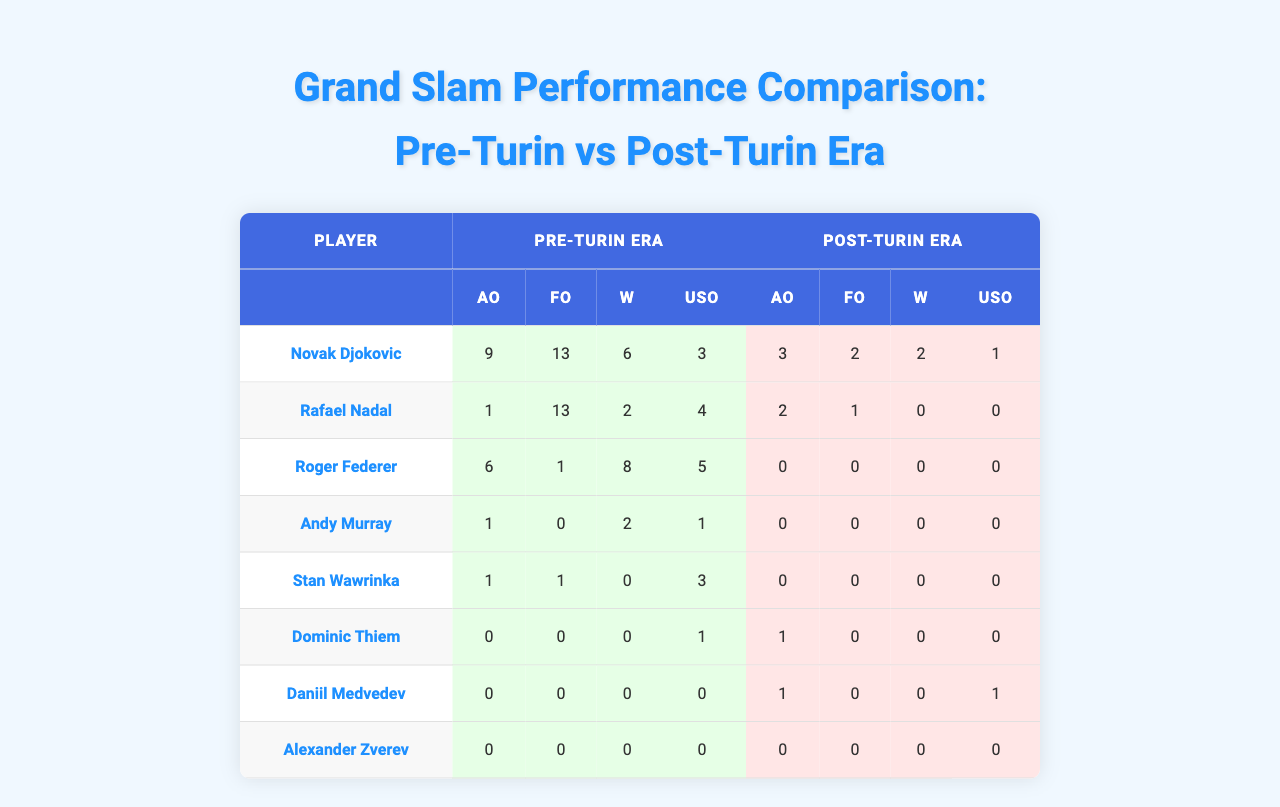What is the total number of Australian Open titles won by Novak Djokovic in the pre-Turin era? Referring to the table, the "Pre-Turin Era" column for Novak Djokovic under Australian Open shows a count of 9 titles.
Answer: 9 How many Grand Slam titles did Rafael Nadal win in the French Open during the post-Turin era? The table indicates that Rafael Nadal won 1 title in the French Open when examining the "Post-Turin Era" column.
Answer: 1 What was the total number of titles won by Andy Murray in the pre-Turin era? Adding up the values in the pre-Turin era for Andy Murray: (1 + 0 + 2 + 1) = 4 titles.
Answer: 4 Did Roger Federer win any titles in the post-Turin era? Looking at the table, Roger Federer has 0 titles in all Grand Slam categories for the post-Turin era. Therefore, the answer is no.
Answer: No Compare the total number of Wimbledon titles won by Stan Wawrinka in both eras. In the pre-Turin era, Stan Wawrinka had 0 titles, while in the post-Turin era, he also had 0 titles. Thus, there is no change.
Answer: No change Which player had the most Grand Slam titles in the Australian Open during the pre-Turin era? Novak Djokovic with 9 titles had the highest count in the Australian Open for the pre-Turin era.
Answer: Novak Djokovic Are there any players who did not win any Grand Slam titles in the post-Turin era? Analyzing the post-Turin era titles, both Andy Murray and Stan Wawrinka won 0 titles, confirming the statement is true.
Answer: Yes Which player had a decrease in total Grand Slam titles from the pre-Turin era to the post-Turin era? By comparing totals, both Novak Djokovic and Rafael Nadal had titles in the pre-Turin era, but their counts decreased in the post-Turin era, confirming a decrease.
Answer: Novak Djokovic and Rafael Nadal What is the difference in the total titles won by Daniil Medvedev between both eras? Adding Daniil Medvedev’s titles: 0 in pre-Turin and 2 in post-Turin gives a total of 2, showing an increase of 2 titles from one era to the next.
Answer: 2 titles increase What is the sum of all Grand Slam titles won by Roger Federer in both eras? For Roger Federer: Pre-Turin (6 + 1 + 8 + 5 = 20), Post-Turin titles sum to 0. Total is 20.
Answer: 20 Which player had the highest number of titles overall in pre-Turin era across all Grand Slams? Calculating totals reveals that Novak Djokovic has the highest overall total with 31 titles (9 + 13 + 6 + 3 = 31).
Answer: Novak Djokovic 